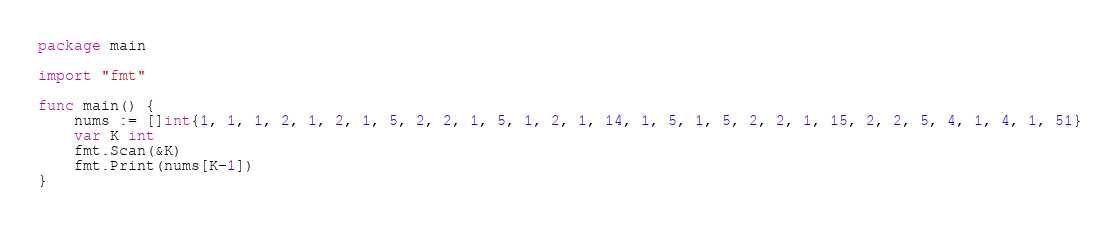Convert code to text. <code><loc_0><loc_0><loc_500><loc_500><_Go_>package main

import "fmt"

func main() {
	nums := []int{1, 1, 1, 2, 1, 2, 1, 5, 2, 2, 1, 5, 1, 2, 1, 14, 1, 5, 1, 5, 2, 2, 1, 15, 2, 2, 5, 4, 1, 4, 1, 51}
	var K int
	fmt.Scan(&K)
	fmt.Print(nums[K-1])
}
</code> 